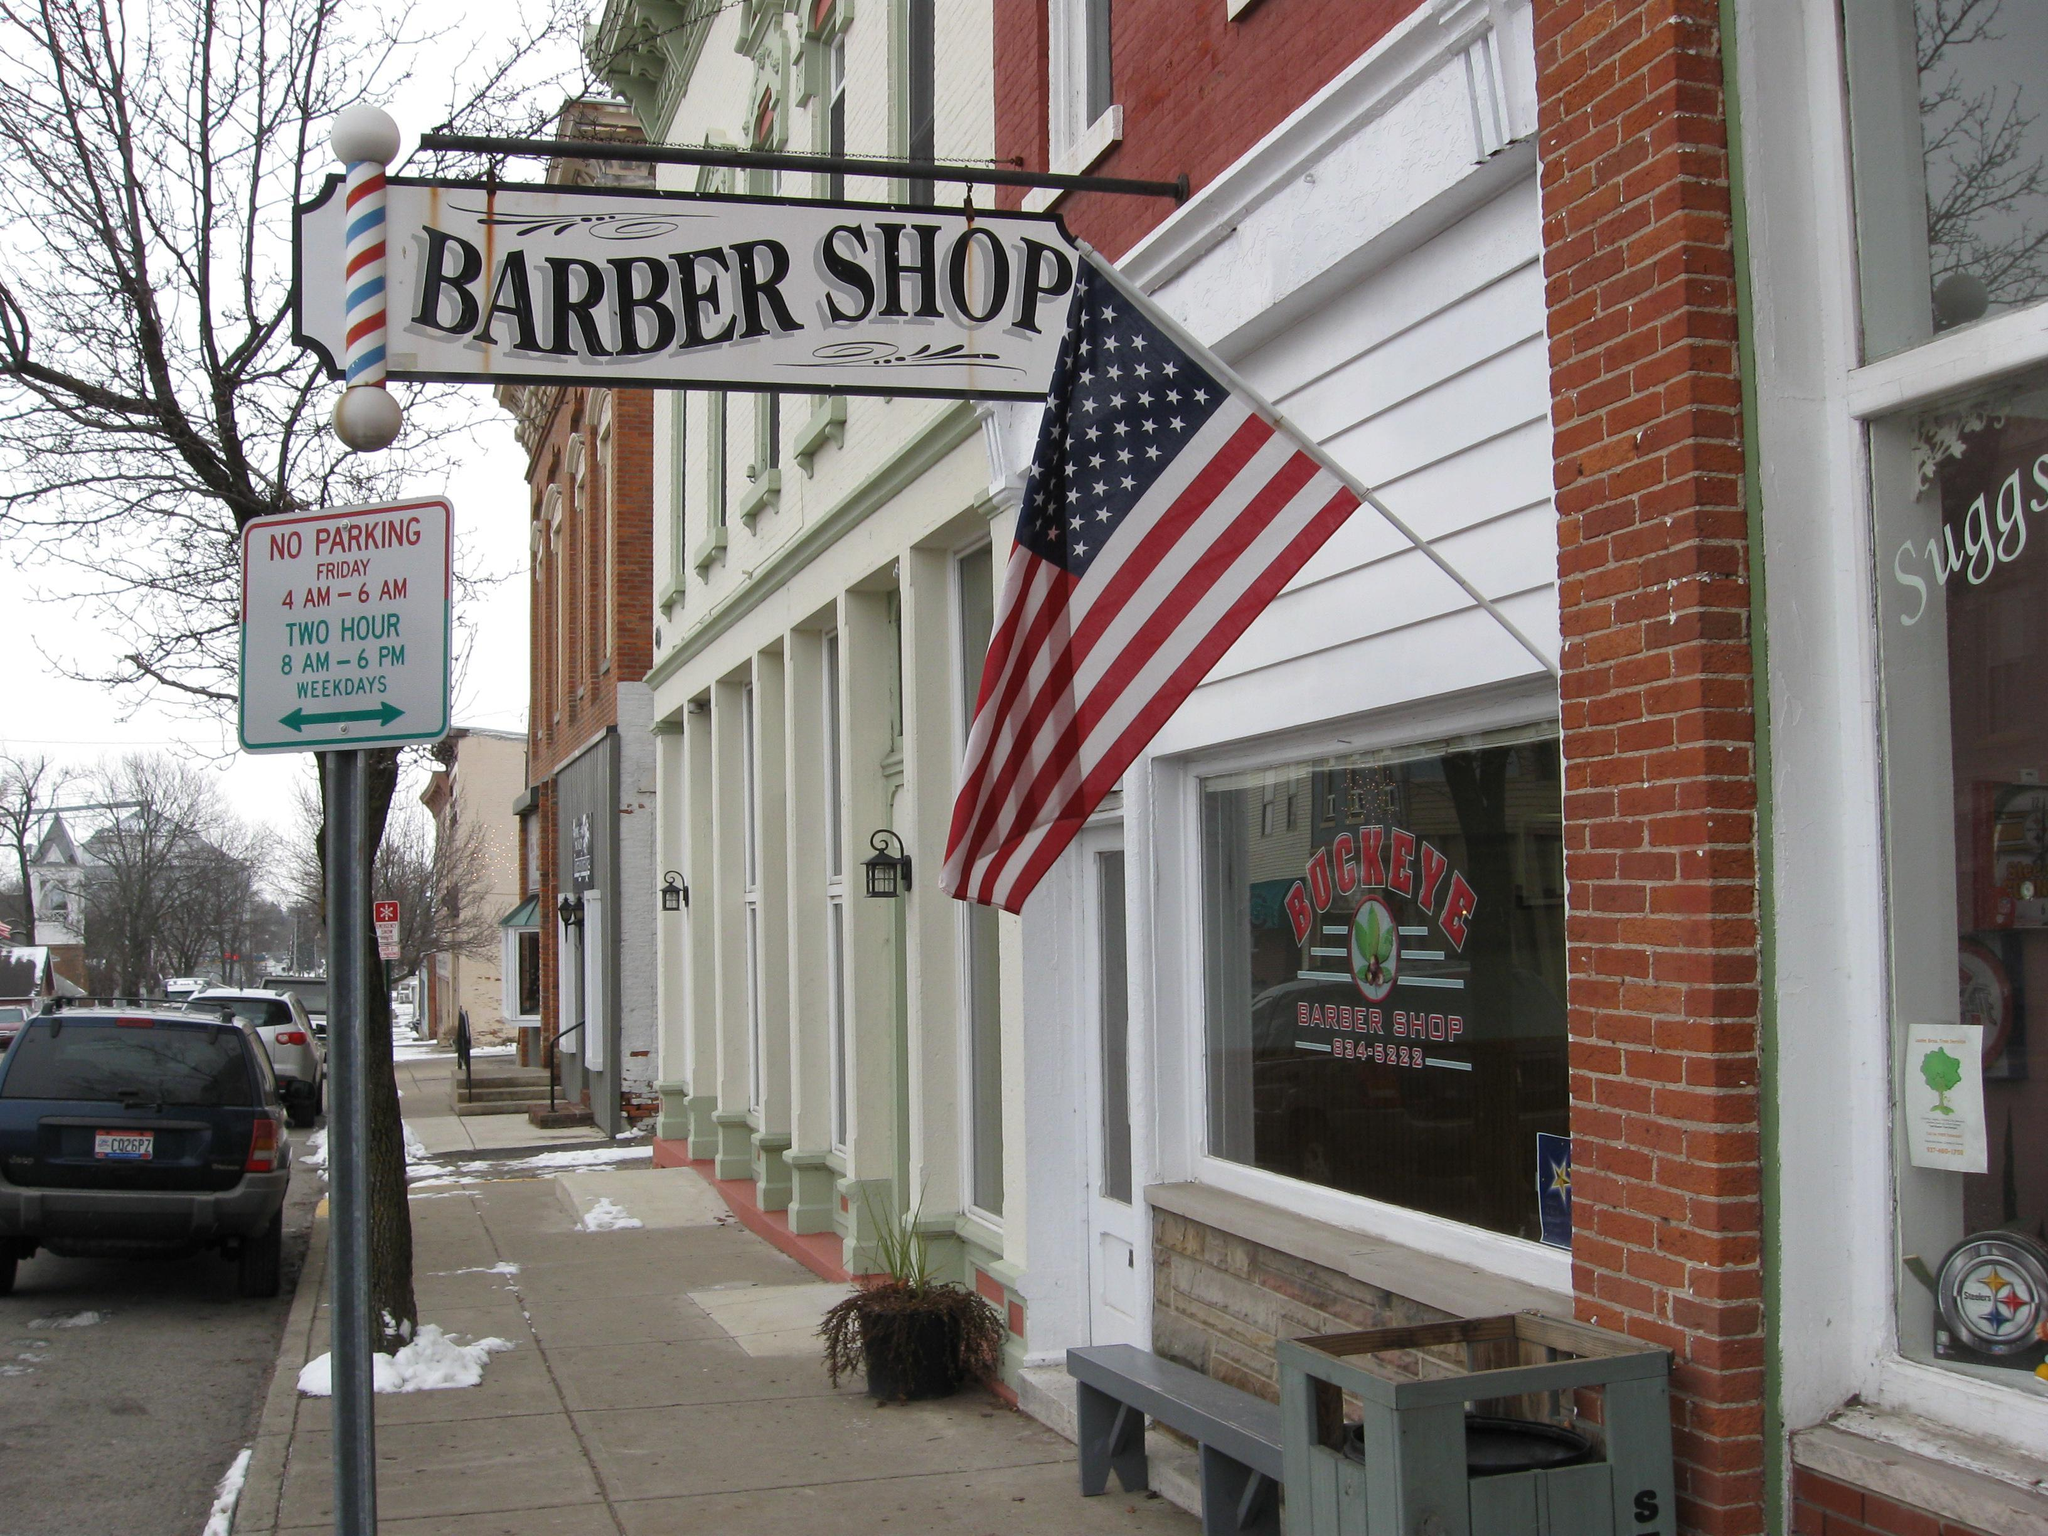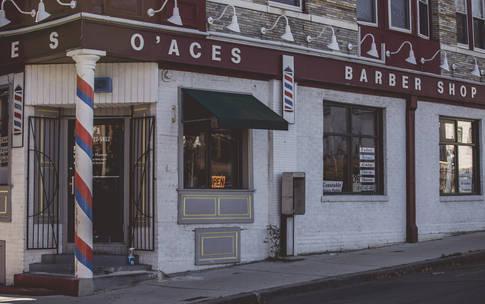The first image is the image on the left, the second image is the image on the right. Considering the images on both sides, is "A truck is visible in one image, and at least one car is visible in each image." valid? Answer yes or no. No. The first image is the image on the left, the second image is the image on the right. For the images shown, is this caption "There is at least one barber pole in the image on the right" true? Answer yes or no. Yes. 